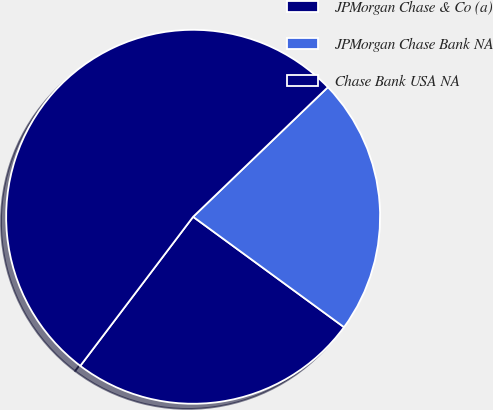Convert chart to OTSL. <chart><loc_0><loc_0><loc_500><loc_500><pie_chart><fcel>JPMorgan Chase & Co (a)<fcel>JPMorgan Chase Bank NA<fcel>Chase Bank USA NA<nl><fcel>25.26%<fcel>22.24%<fcel>52.5%<nl></chart> 